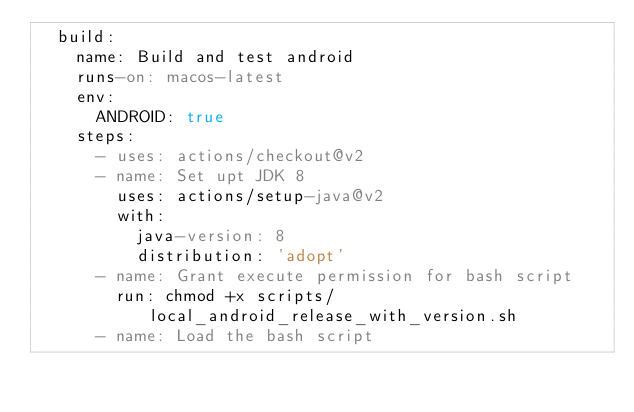Convert code to text. <code><loc_0><loc_0><loc_500><loc_500><_YAML_>  build:
    name: Build and test android
    runs-on: macos-latest
    env:
      ANDROID: true
    steps:
      - uses: actions/checkout@v2
      - name: Set upt JDK 8
        uses: actions/setup-java@v2
        with:
          java-version: 8
          distribution: 'adopt'
      - name: Grant execute permission for bash script
        run: chmod +x scripts/local_android_release_with_version.sh
      - name: Load the bash script</code> 